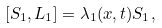Convert formula to latex. <formula><loc_0><loc_0><loc_500><loc_500>[ S _ { 1 } , L _ { 1 } ] = \lambda _ { 1 } ( x , t ) S _ { 1 } ,</formula> 